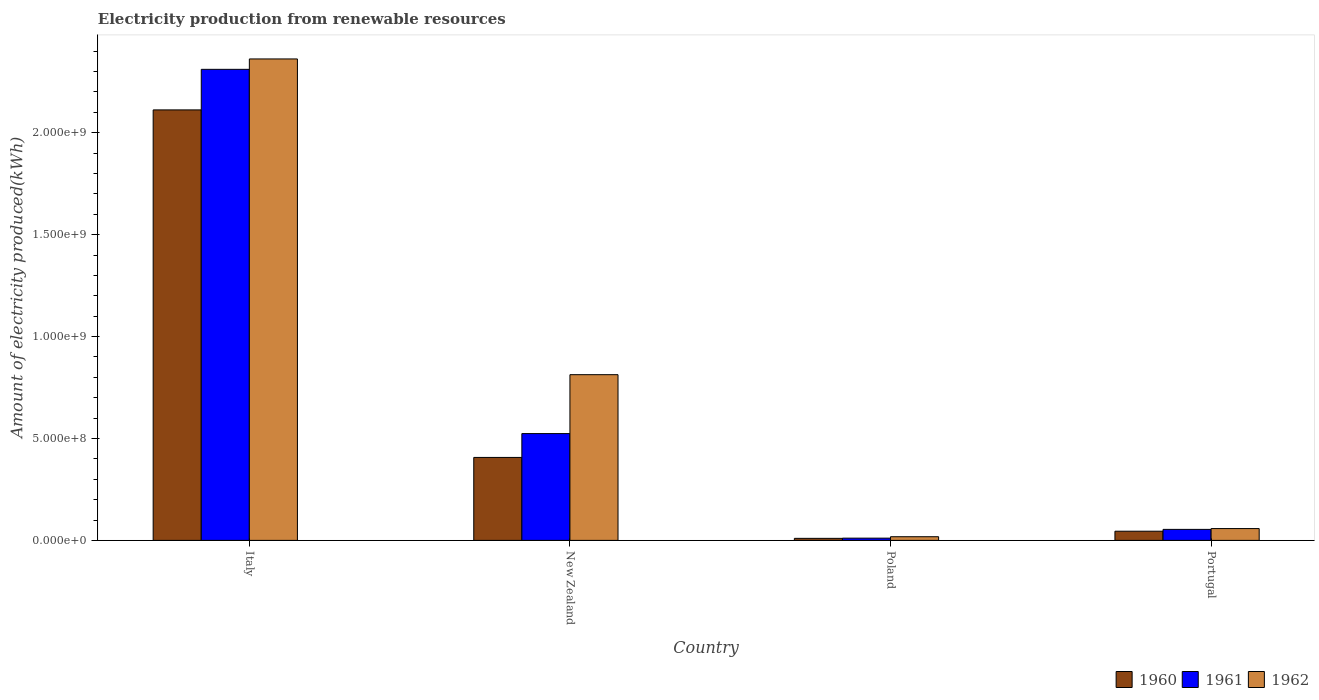Are the number of bars per tick equal to the number of legend labels?
Make the answer very short. Yes. Are the number of bars on each tick of the X-axis equal?
Your answer should be compact. Yes. How many bars are there on the 2nd tick from the left?
Your answer should be compact. 3. What is the label of the 2nd group of bars from the left?
Offer a very short reply. New Zealand. What is the amount of electricity produced in 1960 in Portugal?
Offer a terse response. 4.50e+07. Across all countries, what is the maximum amount of electricity produced in 1960?
Your response must be concise. 2.11e+09. Across all countries, what is the minimum amount of electricity produced in 1961?
Your answer should be compact. 1.10e+07. In which country was the amount of electricity produced in 1961 minimum?
Your response must be concise. Poland. What is the total amount of electricity produced in 1962 in the graph?
Your response must be concise. 3.25e+09. What is the difference between the amount of electricity produced in 1961 in Italy and that in Poland?
Give a very brief answer. 2.30e+09. What is the difference between the amount of electricity produced in 1962 in Poland and the amount of electricity produced in 1961 in Italy?
Provide a short and direct response. -2.29e+09. What is the average amount of electricity produced in 1960 per country?
Your response must be concise. 6.44e+08. In how many countries, is the amount of electricity produced in 1960 greater than 800000000 kWh?
Offer a terse response. 1. What is the ratio of the amount of electricity produced in 1961 in Italy to that in New Zealand?
Your answer should be compact. 4.41. Is the amount of electricity produced in 1960 in New Zealand less than that in Portugal?
Give a very brief answer. No. Is the difference between the amount of electricity produced in 1960 in Italy and Poland greater than the difference between the amount of electricity produced in 1961 in Italy and Poland?
Offer a terse response. No. What is the difference between the highest and the second highest amount of electricity produced in 1960?
Your answer should be compact. 2.07e+09. What is the difference between the highest and the lowest amount of electricity produced in 1960?
Provide a succinct answer. 2.10e+09. In how many countries, is the amount of electricity produced in 1961 greater than the average amount of electricity produced in 1961 taken over all countries?
Your response must be concise. 1. What does the 1st bar from the left in Italy represents?
Your answer should be compact. 1960. What does the 1st bar from the right in Poland represents?
Keep it short and to the point. 1962. How many bars are there?
Provide a succinct answer. 12. Does the graph contain grids?
Your answer should be very brief. No. What is the title of the graph?
Provide a short and direct response. Electricity production from renewable resources. Does "1983" appear as one of the legend labels in the graph?
Offer a very short reply. No. What is the label or title of the X-axis?
Ensure brevity in your answer.  Country. What is the label or title of the Y-axis?
Offer a terse response. Amount of electricity produced(kWh). What is the Amount of electricity produced(kWh) of 1960 in Italy?
Provide a succinct answer. 2.11e+09. What is the Amount of electricity produced(kWh) in 1961 in Italy?
Offer a very short reply. 2.31e+09. What is the Amount of electricity produced(kWh) of 1962 in Italy?
Offer a terse response. 2.36e+09. What is the Amount of electricity produced(kWh) of 1960 in New Zealand?
Offer a terse response. 4.07e+08. What is the Amount of electricity produced(kWh) of 1961 in New Zealand?
Offer a terse response. 5.24e+08. What is the Amount of electricity produced(kWh) of 1962 in New Zealand?
Make the answer very short. 8.13e+08. What is the Amount of electricity produced(kWh) of 1960 in Poland?
Make the answer very short. 1.00e+07. What is the Amount of electricity produced(kWh) in 1961 in Poland?
Offer a terse response. 1.10e+07. What is the Amount of electricity produced(kWh) of 1962 in Poland?
Provide a short and direct response. 1.80e+07. What is the Amount of electricity produced(kWh) in 1960 in Portugal?
Your response must be concise. 4.50e+07. What is the Amount of electricity produced(kWh) in 1961 in Portugal?
Provide a short and direct response. 5.40e+07. What is the Amount of electricity produced(kWh) of 1962 in Portugal?
Offer a very short reply. 5.80e+07. Across all countries, what is the maximum Amount of electricity produced(kWh) in 1960?
Offer a terse response. 2.11e+09. Across all countries, what is the maximum Amount of electricity produced(kWh) of 1961?
Make the answer very short. 2.31e+09. Across all countries, what is the maximum Amount of electricity produced(kWh) in 1962?
Keep it short and to the point. 2.36e+09. Across all countries, what is the minimum Amount of electricity produced(kWh) of 1960?
Your response must be concise. 1.00e+07. Across all countries, what is the minimum Amount of electricity produced(kWh) of 1961?
Keep it short and to the point. 1.10e+07. Across all countries, what is the minimum Amount of electricity produced(kWh) of 1962?
Your response must be concise. 1.80e+07. What is the total Amount of electricity produced(kWh) of 1960 in the graph?
Keep it short and to the point. 2.57e+09. What is the total Amount of electricity produced(kWh) in 1961 in the graph?
Make the answer very short. 2.90e+09. What is the total Amount of electricity produced(kWh) in 1962 in the graph?
Your answer should be very brief. 3.25e+09. What is the difference between the Amount of electricity produced(kWh) of 1960 in Italy and that in New Zealand?
Give a very brief answer. 1.70e+09. What is the difference between the Amount of electricity produced(kWh) of 1961 in Italy and that in New Zealand?
Offer a very short reply. 1.79e+09. What is the difference between the Amount of electricity produced(kWh) of 1962 in Italy and that in New Zealand?
Ensure brevity in your answer.  1.55e+09. What is the difference between the Amount of electricity produced(kWh) of 1960 in Italy and that in Poland?
Offer a very short reply. 2.10e+09. What is the difference between the Amount of electricity produced(kWh) of 1961 in Italy and that in Poland?
Offer a very short reply. 2.30e+09. What is the difference between the Amount of electricity produced(kWh) of 1962 in Italy and that in Poland?
Your answer should be very brief. 2.34e+09. What is the difference between the Amount of electricity produced(kWh) in 1960 in Italy and that in Portugal?
Provide a short and direct response. 2.07e+09. What is the difference between the Amount of electricity produced(kWh) in 1961 in Italy and that in Portugal?
Provide a succinct answer. 2.26e+09. What is the difference between the Amount of electricity produced(kWh) of 1962 in Italy and that in Portugal?
Your answer should be compact. 2.30e+09. What is the difference between the Amount of electricity produced(kWh) of 1960 in New Zealand and that in Poland?
Your response must be concise. 3.97e+08. What is the difference between the Amount of electricity produced(kWh) in 1961 in New Zealand and that in Poland?
Your response must be concise. 5.13e+08. What is the difference between the Amount of electricity produced(kWh) of 1962 in New Zealand and that in Poland?
Your answer should be very brief. 7.95e+08. What is the difference between the Amount of electricity produced(kWh) in 1960 in New Zealand and that in Portugal?
Your answer should be very brief. 3.62e+08. What is the difference between the Amount of electricity produced(kWh) of 1961 in New Zealand and that in Portugal?
Your response must be concise. 4.70e+08. What is the difference between the Amount of electricity produced(kWh) of 1962 in New Zealand and that in Portugal?
Offer a terse response. 7.55e+08. What is the difference between the Amount of electricity produced(kWh) of 1960 in Poland and that in Portugal?
Ensure brevity in your answer.  -3.50e+07. What is the difference between the Amount of electricity produced(kWh) of 1961 in Poland and that in Portugal?
Keep it short and to the point. -4.30e+07. What is the difference between the Amount of electricity produced(kWh) in 1962 in Poland and that in Portugal?
Ensure brevity in your answer.  -4.00e+07. What is the difference between the Amount of electricity produced(kWh) of 1960 in Italy and the Amount of electricity produced(kWh) of 1961 in New Zealand?
Your answer should be compact. 1.59e+09. What is the difference between the Amount of electricity produced(kWh) in 1960 in Italy and the Amount of electricity produced(kWh) in 1962 in New Zealand?
Give a very brief answer. 1.30e+09. What is the difference between the Amount of electricity produced(kWh) of 1961 in Italy and the Amount of electricity produced(kWh) of 1962 in New Zealand?
Offer a terse response. 1.50e+09. What is the difference between the Amount of electricity produced(kWh) in 1960 in Italy and the Amount of electricity produced(kWh) in 1961 in Poland?
Make the answer very short. 2.10e+09. What is the difference between the Amount of electricity produced(kWh) in 1960 in Italy and the Amount of electricity produced(kWh) in 1962 in Poland?
Give a very brief answer. 2.09e+09. What is the difference between the Amount of electricity produced(kWh) of 1961 in Italy and the Amount of electricity produced(kWh) of 1962 in Poland?
Provide a succinct answer. 2.29e+09. What is the difference between the Amount of electricity produced(kWh) of 1960 in Italy and the Amount of electricity produced(kWh) of 1961 in Portugal?
Your answer should be very brief. 2.06e+09. What is the difference between the Amount of electricity produced(kWh) of 1960 in Italy and the Amount of electricity produced(kWh) of 1962 in Portugal?
Ensure brevity in your answer.  2.05e+09. What is the difference between the Amount of electricity produced(kWh) of 1961 in Italy and the Amount of electricity produced(kWh) of 1962 in Portugal?
Offer a very short reply. 2.25e+09. What is the difference between the Amount of electricity produced(kWh) in 1960 in New Zealand and the Amount of electricity produced(kWh) in 1961 in Poland?
Make the answer very short. 3.96e+08. What is the difference between the Amount of electricity produced(kWh) in 1960 in New Zealand and the Amount of electricity produced(kWh) in 1962 in Poland?
Your answer should be compact. 3.89e+08. What is the difference between the Amount of electricity produced(kWh) in 1961 in New Zealand and the Amount of electricity produced(kWh) in 1962 in Poland?
Offer a very short reply. 5.06e+08. What is the difference between the Amount of electricity produced(kWh) of 1960 in New Zealand and the Amount of electricity produced(kWh) of 1961 in Portugal?
Your response must be concise. 3.53e+08. What is the difference between the Amount of electricity produced(kWh) in 1960 in New Zealand and the Amount of electricity produced(kWh) in 1962 in Portugal?
Offer a terse response. 3.49e+08. What is the difference between the Amount of electricity produced(kWh) in 1961 in New Zealand and the Amount of electricity produced(kWh) in 1962 in Portugal?
Provide a succinct answer. 4.66e+08. What is the difference between the Amount of electricity produced(kWh) of 1960 in Poland and the Amount of electricity produced(kWh) of 1961 in Portugal?
Give a very brief answer. -4.40e+07. What is the difference between the Amount of electricity produced(kWh) of 1960 in Poland and the Amount of electricity produced(kWh) of 1962 in Portugal?
Provide a short and direct response. -4.80e+07. What is the difference between the Amount of electricity produced(kWh) in 1961 in Poland and the Amount of electricity produced(kWh) in 1962 in Portugal?
Your answer should be very brief. -4.70e+07. What is the average Amount of electricity produced(kWh) in 1960 per country?
Your answer should be compact. 6.44e+08. What is the average Amount of electricity produced(kWh) of 1961 per country?
Keep it short and to the point. 7.25e+08. What is the average Amount of electricity produced(kWh) of 1962 per country?
Make the answer very short. 8.13e+08. What is the difference between the Amount of electricity produced(kWh) of 1960 and Amount of electricity produced(kWh) of 1961 in Italy?
Make the answer very short. -1.99e+08. What is the difference between the Amount of electricity produced(kWh) of 1960 and Amount of electricity produced(kWh) of 1962 in Italy?
Provide a succinct answer. -2.50e+08. What is the difference between the Amount of electricity produced(kWh) in 1961 and Amount of electricity produced(kWh) in 1962 in Italy?
Keep it short and to the point. -5.10e+07. What is the difference between the Amount of electricity produced(kWh) in 1960 and Amount of electricity produced(kWh) in 1961 in New Zealand?
Provide a succinct answer. -1.17e+08. What is the difference between the Amount of electricity produced(kWh) in 1960 and Amount of electricity produced(kWh) in 1962 in New Zealand?
Make the answer very short. -4.06e+08. What is the difference between the Amount of electricity produced(kWh) of 1961 and Amount of electricity produced(kWh) of 1962 in New Zealand?
Provide a succinct answer. -2.89e+08. What is the difference between the Amount of electricity produced(kWh) in 1960 and Amount of electricity produced(kWh) in 1961 in Poland?
Your answer should be compact. -1.00e+06. What is the difference between the Amount of electricity produced(kWh) in 1960 and Amount of electricity produced(kWh) in 1962 in Poland?
Provide a short and direct response. -8.00e+06. What is the difference between the Amount of electricity produced(kWh) in 1961 and Amount of electricity produced(kWh) in 1962 in Poland?
Provide a succinct answer. -7.00e+06. What is the difference between the Amount of electricity produced(kWh) in 1960 and Amount of electricity produced(kWh) in 1961 in Portugal?
Your answer should be very brief. -9.00e+06. What is the difference between the Amount of electricity produced(kWh) of 1960 and Amount of electricity produced(kWh) of 1962 in Portugal?
Provide a succinct answer. -1.30e+07. What is the difference between the Amount of electricity produced(kWh) of 1961 and Amount of electricity produced(kWh) of 1962 in Portugal?
Offer a terse response. -4.00e+06. What is the ratio of the Amount of electricity produced(kWh) of 1960 in Italy to that in New Zealand?
Make the answer very short. 5.19. What is the ratio of the Amount of electricity produced(kWh) of 1961 in Italy to that in New Zealand?
Keep it short and to the point. 4.41. What is the ratio of the Amount of electricity produced(kWh) in 1962 in Italy to that in New Zealand?
Provide a succinct answer. 2.91. What is the ratio of the Amount of electricity produced(kWh) of 1960 in Italy to that in Poland?
Offer a very short reply. 211.2. What is the ratio of the Amount of electricity produced(kWh) in 1961 in Italy to that in Poland?
Keep it short and to the point. 210.09. What is the ratio of the Amount of electricity produced(kWh) in 1962 in Italy to that in Poland?
Offer a very short reply. 131.22. What is the ratio of the Amount of electricity produced(kWh) of 1960 in Italy to that in Portugal?
Keep it short and to the point. 46.93. What is the ratio of the Amount of electricity produced(kWh) of 1961 in Italy to that in Portugal?
Provide a short and direct response. 42.8. What is the ratio of the Amount of electricity produced(kWh) in 1962 in Italy to that in Portugal?
Keep it short and to the point. 40.72. What is the ratio of the Amount of electricity produced(kWh) in 1960 in New Zealand to that in Poland?
Ensure brevity in your answer.  40.7. What is the ratio of the Amount of electricity produced(kWh) of 1961 in New Zealand to that in Poland?
Offer a terse response. 47.64. What is the ratio of the Amount of electricity produced(kWh) in 1962 in New Zealand to that in Poland?
Provide a short and direct response. 45.17. What is the ratio of the Amount of electricity produced(kWh) of 1960 in New Zealand to that in Portugal?
Keep it short and to the point. 9.04. What is the ratio of the Amount of electricity produced(kWh) of 1961 in New Zealand to that in Portugal?
Provide a short and direct response. 9.7. What is the ratio of the Amount of electricity produced(kWh) in 1962 in New Zealand to that in Portugal?
Your response must be concise. 14.02. What is the ratio of the Amount of electricity produced(kWh) of 1960 in Poland to that in Portugal?
Ensure brevity in your answer.  0.22. What is the ratio of the Amount of electricity produced(kWh) of 1961 in Poland to that in Portugal?
Your answer should be compact. 0.2. What is the ratio of the Amount of electricity produced(kWh) of 1962 in Poland to that in Portugal?
Your response must be concise. 0.31. What is the difference between the highest and the second highest Amount of electricity produced(kWh) of 1960?
Give a very brief answer. 1.70e+09. What is the difference between the highest and the second highest Amount of electricity produced(kWh) of 1961?
Offer a terse response. 1.79e+09. What is the difference between the highest and the second highest Amount of electricity produced(kWh) of 1962?
Ensure brevity in your answer.  1.55e+09. What is the difference between the highest and the lowest Amount of electricity produced(kWh) of 1960?
Make the answer very short. 2.10e+09. What is the difference between the highest and the lowest Amount of electricity produced(kWh) of 1961?
Keep it short and to the point. 2.30e+09. What is the difference between the highest and the lowest Amount of electricity produced(kWh) in 1962?
Give a very brief answer. 2.34e+09. 